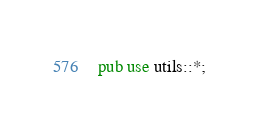<code> <loc_0><loc_0><loc_500><loc_500><_Rust_>pub use utils::*;
</code> 